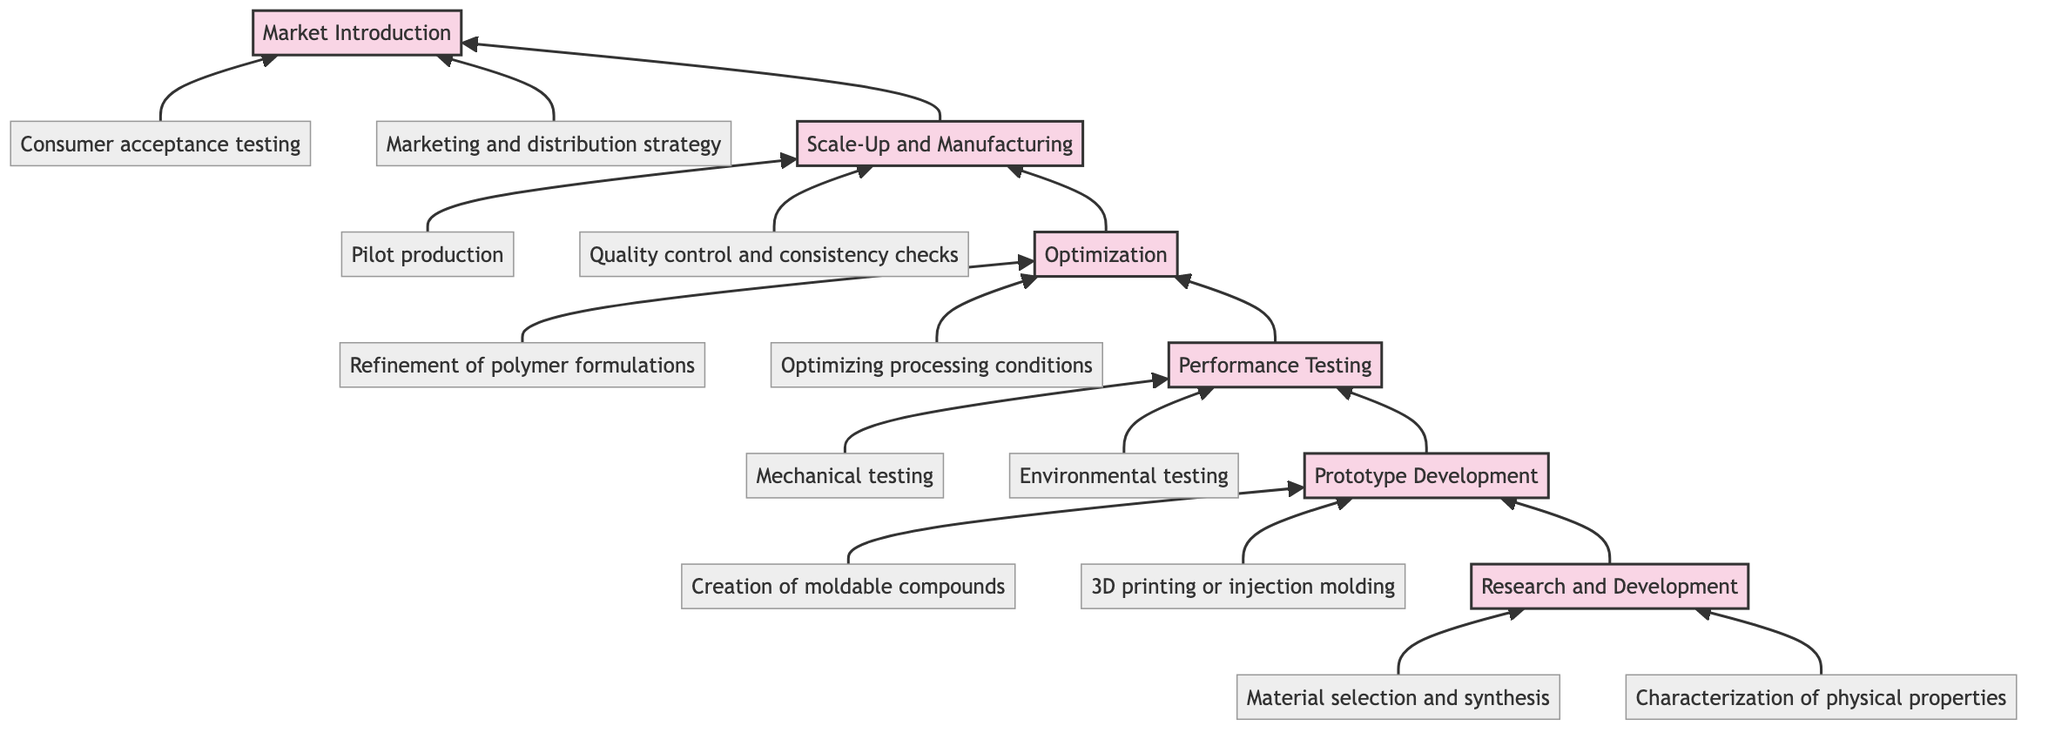What is the top stage of the flow chart? The flow chart has multiple stages, and the topmost stage is "Market Introduction," which is the final step in the development of biodegradable polymers for eco-friendly sports gear.
Answer: Market Introduction How many stages are in the chart? By counting the number of stages listed, which are Research and Development, Prototype Development, Performance Testing, Optimization, Scale-Up and Manufacturing, and Market Introduction, we find there are six stages total.
Answer: 6 What stage comes directly after Performance Testing? Flowing up the chart, the stage that follows Performance Testing is Optimization, which represents a subsequent phase aimed at refining the processes and formulations.
Answer: Optimization Which stages involve testing? The stages that involve testing are Performance Testing, which includes mechanical and environmental testing. Thus, the focus is specifically on evaluating the prototypes before final production.
Answer: Performance Testing What is one detail under Prototype Development? A specific detail listed under Prototype Development is "3D printing or injection molding of preliminary designs," indicating a method for producing the prototypes from the developed materials.
Answer: 3D printing or injection molding of preliminary designs What is the relationship between Scale-Up and Manufacturing? Scale-Up and Manufacturing is the penultimate stage in the flow chart that comes immediately after Optimization, indicating the transition from refinement to production for market-ready products.
Answer: Comes after Optimization How many details are listed under the Research and Development stage? There are two details listed under Research and Development, which are material selection and synthesis, along with characterization of physical properties.
Answer: 2 What kind of testing occurs in Performance Testing? Performance Testing includes both mechanical testing and environmental testing, which evaluates the physical durability and degradation capabilities of the biodegradable polymers.
Answer: Mechanical testing and environmental testing What is the focus of the Optimization stage? The Optimization stage focuses on refining polymer formulations and optimizing processing conditions like temperature and pressure for better performance and suitability for production.
Answer: Refinement of polymer formulations and optimizing processing conditions 